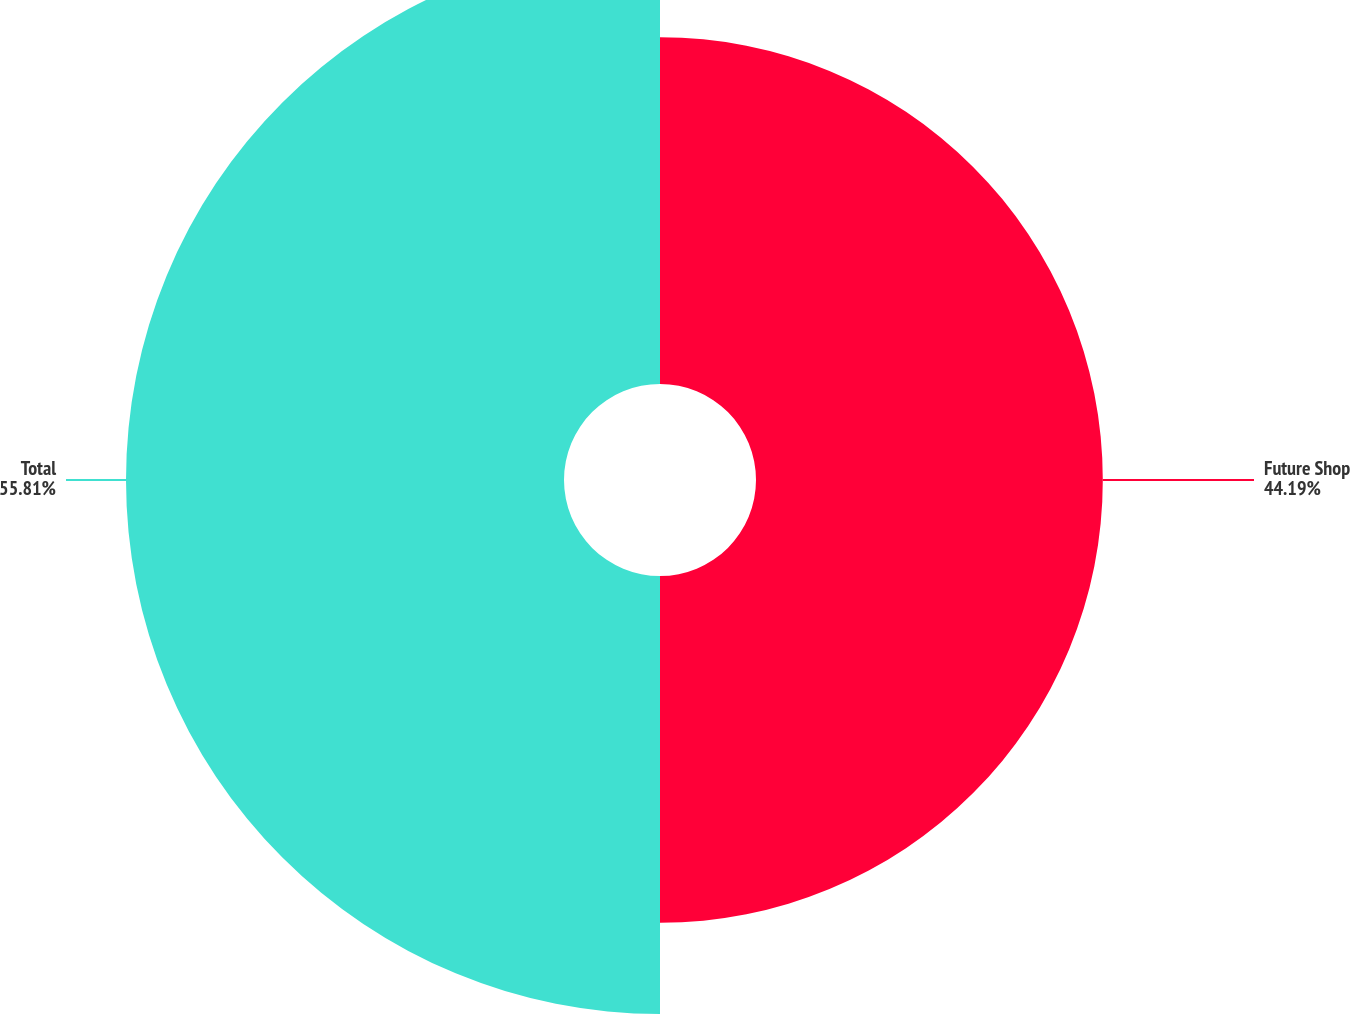Convert chart to OTSL. <chart><loc_0><loc_0><loc_500><loc_500><pie_chart><fcel>Future Shop<fcel>Total<nl><fcel>44.19%<fcel>55.81%<nl></chart> 